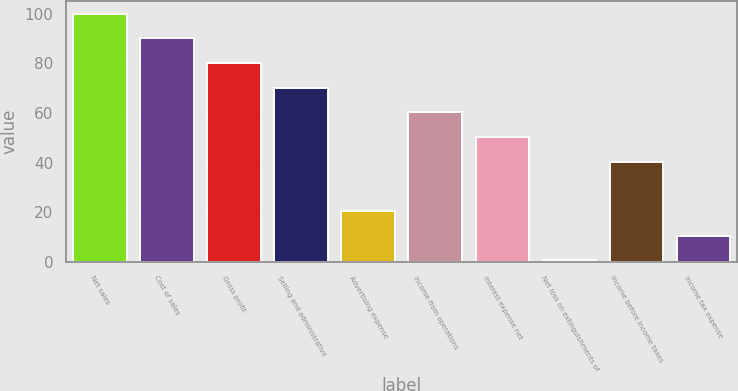Convert chart. <chart><loc_0><loc_0><loc_500><loc_500><bar_chart><fcel>Net sales<fcel>Cost of sales<fcel>Gross profit<fcel>Selling and administrative<fcel>Advertising expense<fcel>Income from operations<fcel>Interest expense net<fcel>Net loss on extinguishments of<fcel>Income before income taxes<fcel>Income tax expense<nl><fcel>100<fcel>90.06<fcel>80.12<fcel>70.18<fcel>20.48<fcel>60.24<fcel>50.3<fcel>0.6<fcel>40.36<fcel>10.54<nl></chart> 